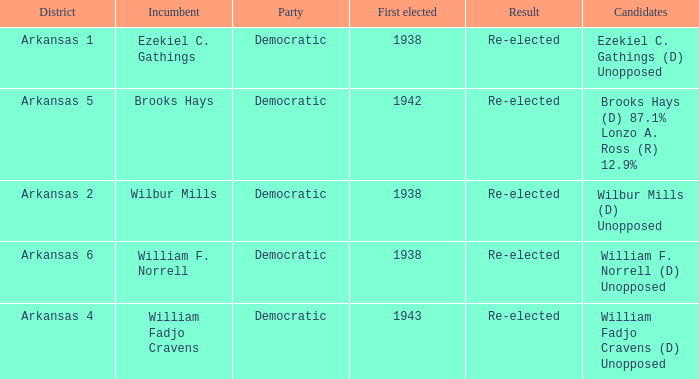What party did incumbent Brooks Hays belong to?  Democratic. 